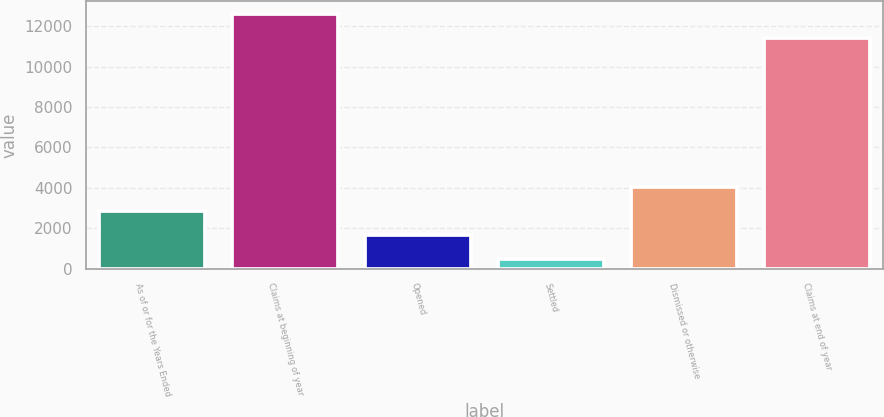Convert chart to OTSL. <chart><loc_0><loc_0><loc_500><loc_500><bar_chart><fcel>As of or for the Years Ended<fcel>Claims at beginning of year<fcel>Opened<fcel>Settled<fcel>Dismissed or otherwise<fcel>Claims at end of year<nl><fcel>2857.2<fcel>12610.6<fcel>1657.6<fcel>458<fcel>4056.8<fcel>11411<nl></chart> 